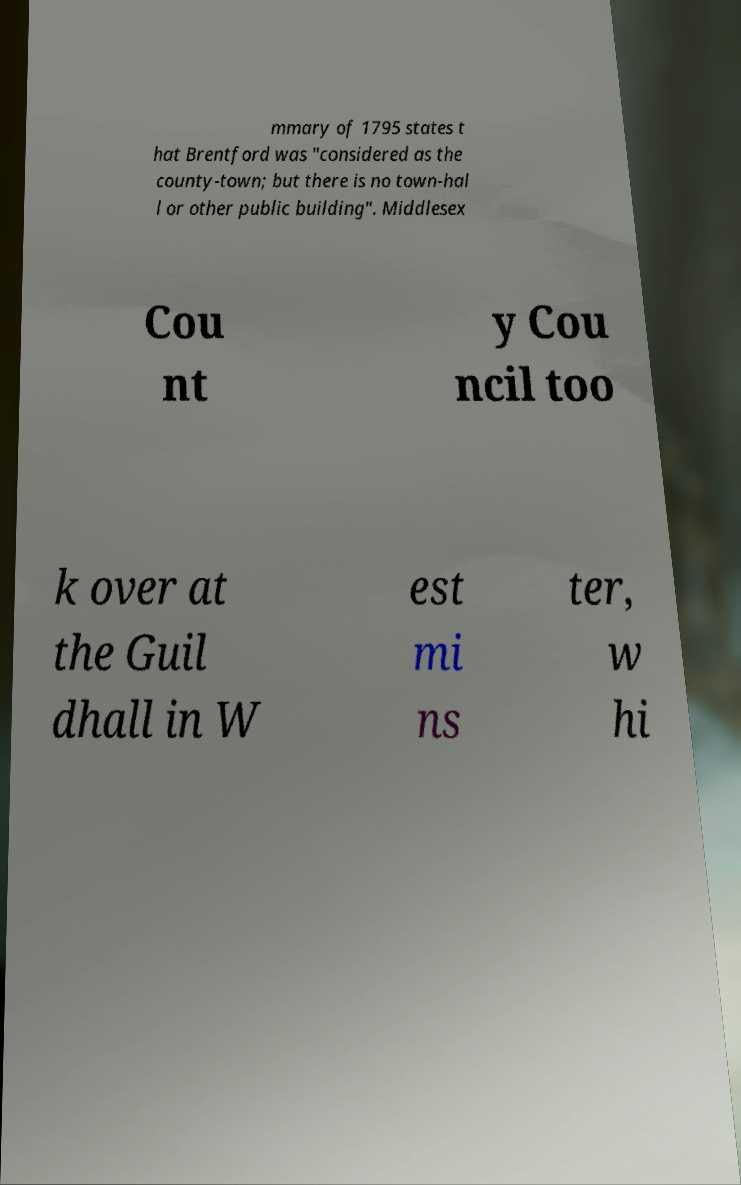There's text embedded in this image that I need extracted. Can you transcribe it verbatim? mmary of 1795 states t hat Brentford was "considered as the county-town; but there is no town-hal l or other public building". Middlesex Cou nt y Cou ncil too k over at the Guil dhall in W est mi ns ter, w hi 